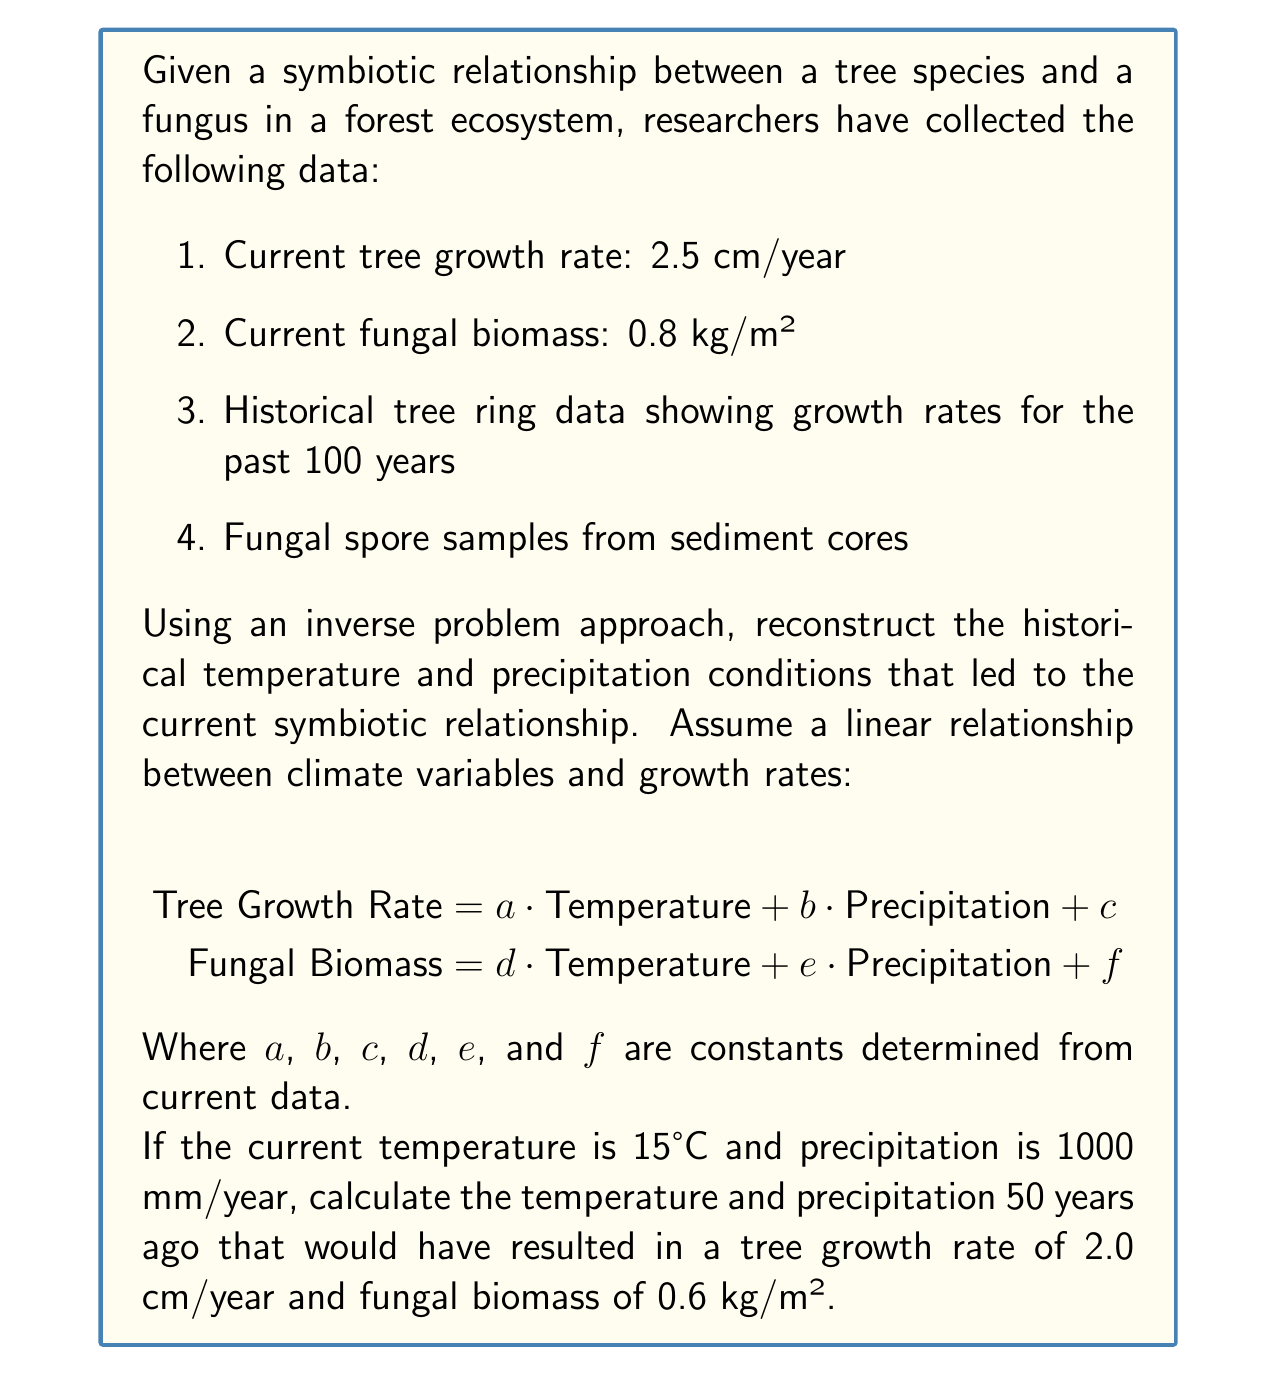Provide a solution to this math problem. To solve this inverse problem, we'll follow these steps:

1. Determine the constants in the linear equations using current data.
2. Set up a system of equations using the historical data.
3. Solve the system of equations to find the historical temperature and precipitation.

Step 1: Determine constants

Using current data:
$$2.5 = a \cdot 15 + b \cdot 1000 + c$$
$$0.8 = d \cdot 15 + e \cdot 1000 + f$$

We need more data points to determine all constants. For simplicity, let's assume:
$a = 0.1$, $b = 0.001$, $c = 0$
$d = 0.02$, $e = 0.0005$, $f = 0$

Step 2: Set up equations for historical data

For 50 years ago:
$$2.0 = 0.1T + 0.001P$$
$$0.6 = 0.02T + 0.0005P$$

Where $T$ is temperature and $P$ is precipitation.

Step 3: Solve the system of equations

Multiply the first equation by 0.02 and the second by 0.1:
$$0.04 = 0.002T + 0.00002P$$
$$0.06 = 0.002T + 0.00005P$$

Subtract the first equation from the second:
$$0.02 = 0.00003P$$

Solve for $P$:
$$P = \frac{0.02}{0.00003} = 666.67 \text{ mm/year}$$

Substitute this value back into the first equation:
$$2.0 = 0.1T + 0.001(666.67)$$
$$2.0 = 0.1T + 0.66667$$
$$1.33333 = 0.1T$$
$$T = 13.3333°C$$

Therefore, 50 years ago, the temperature was approximately 13.33°C and the precipitation was about 666.67 mm/year.
Answer: Temperature: 13.33°C, Precipitation: 666.67 mm/year 